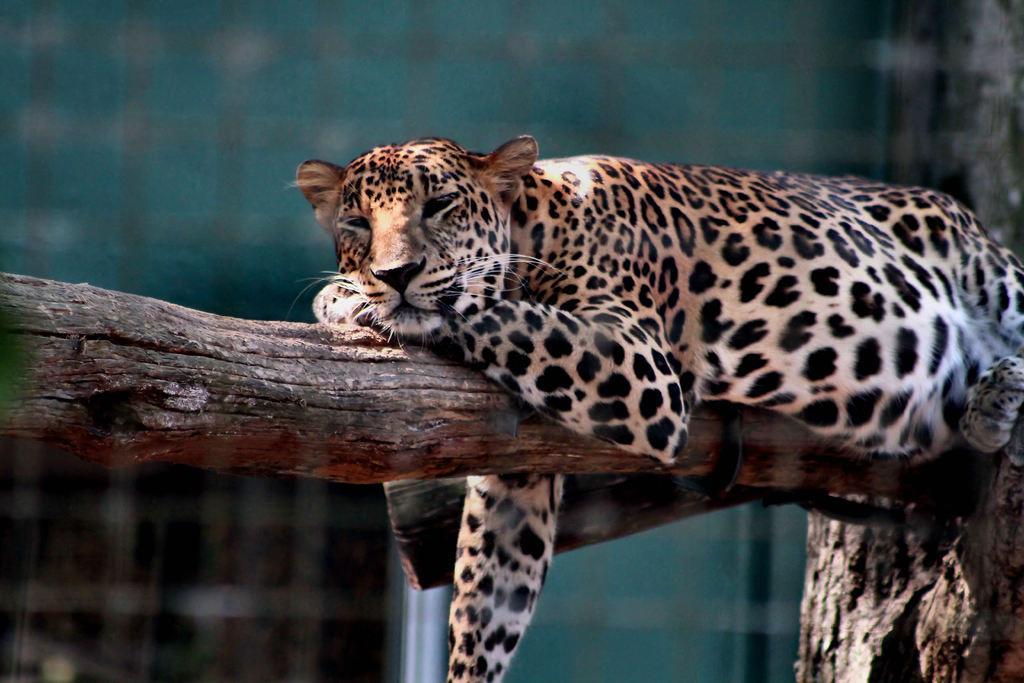In one or two sentences, can you explain what this image depicts? In this image, we can see cheetah lying on the branch. 